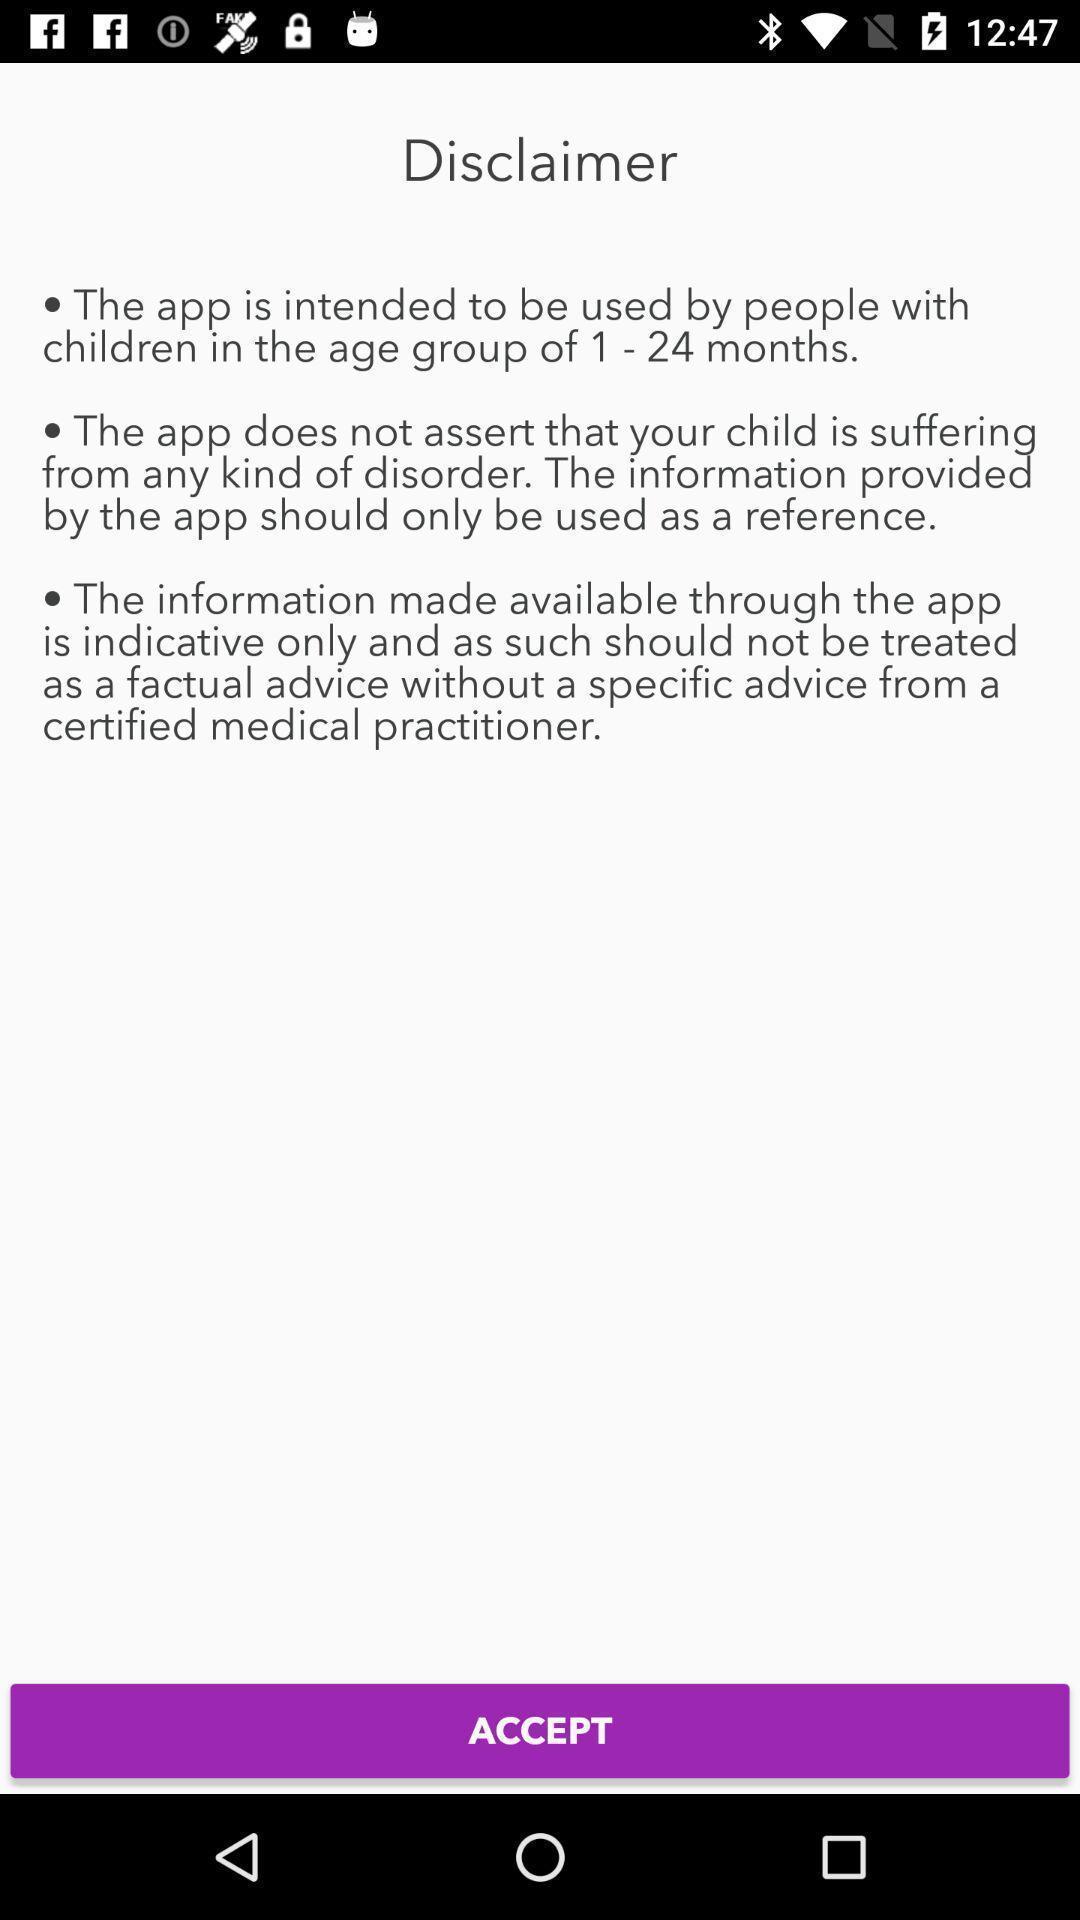Summarize the information in this screenshot. Terms of the application to accept. 